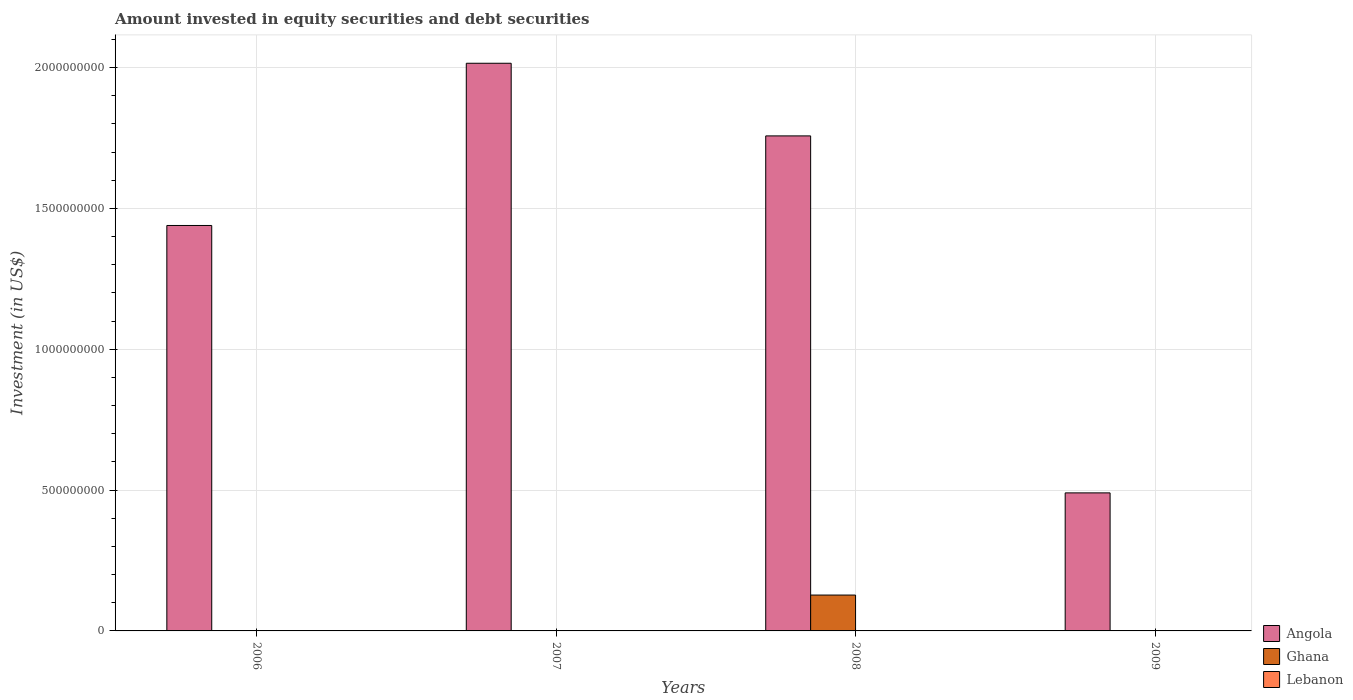How many different coloured bars are there?
Make the answer very short. 2. Are the number of bars per tick equal to the number of legend labels?
Offer a terse response. No. Are the number of bars on each tick of the X-axis equal?
Make the answer very short. No. What is the label of the 1st group of bars from the left?
Your response must be concise. 2006. In how many cases, is the number of bars for a given year not equal to the number of legend labels?
Offer a very short reply. 4. Across all years, what is the maximum amount invested in equity securities and debt securities in Ghana?
Provide a short and direct response. 1.27e+08. What is the total amount invested in equity securities and debt securities in Ghana in the graph?
Your response must be concise. 1.27e+08. What is the difference between the amount invested in equity securities and debt securities in Angola in 2006 and that in 2007?
Your response must be concise. -5.76e+08. What is the difference between the amount invested in equity securities and debt securities in Lebanon in 2009 and the amount invested in equity securities and debt securities in Angola in 2006?
Provide a short and direct response. -1.44e+09. What is the average amount invested in equity securities and debt securities in Angola per year?
Keep it short and to the point. 1.43e+09. In the year 2008, what is the difference between the amount invested in equity securities and debt securities in Ghana and amount invested in equity securities and debt securities in Angola?
Provide a short and direct response. -1.63e+09. In how many years, is the amount invested in equity securities and debt securities in Angola greater than 1500000000 US$?
Provide a succinct answer. 2. What is the ratio of the amount invested in equity securities and debt securities in Angola in 2008 to that in 2009?
Provide a succinct answer. 3.59. Is the amount invested in equity securities and debt securities in Angola in 2007 less than that in 2008?
Make the answer very short. No. What is the difference between the highest and the second highest amount invested in equity securities and debt securities in Angola?
Your answer should be compact. 2.58e+08. What is the difference between the highest and the lowest amount invested in equity securities and debt securities in Ghana?
Offer a terse response. 1.27e+08. Is the sum of the amount invested in equity securities and debt securities in Angola in 2007 and 2009 greater than the maximum amount invested in equity securities and debt securities in Ghana across all years?
Your response must be concise. Yes. Is it the case that in every year, the sum of the amount invested in equity securities and debt securities in Angola and amount invested in equity securities and debt securities in Ghana is greater than the amount invested in equity securities and debt securities in Lebanon?
Keep it short and to the point. Yes. How many bars are there?
Your answer should be very brief. 5. Are all the bars in the graph horizontal?
Offer a very short reply. No. How many years are there in the graph?
Give a very brief answer. 4. Does the graph contain any zero values?
Your answer should be very brief. Yes. Does the graph contain grids?
Ensure brevity in your answer.  Yes. What is the title of the graph?
Ensure brevity in your answer.  Amount invested in equity securities and debt securities. Does "Fragile and conflict affected situations" appear as one of the legend labels in the graph?
Offer a terse response. No. What is the label or title of the Y-axis?
Give a very brief answer. Investment (in US$). What is the Investment (in US$) in Angola in 2006?
Keep it short and to the point. 1.44e+09. What is the Investment (in US$) in Lebanon in 2006?
Keep it short and to the point. 0. What is the Investment (in US$) in Angola in 2007?
Offer a terse response. 2.02e+09. What is the Investment (in US$) in Lebanon in 2007?
Provide a short and direct response. 0. What is the Investment (in US$) in Angola in 2008?
Give a very brief answer. 1.76e+09. What is the Investment (in US$) in Ghana in 2008?
Your answer should be very brief. 1.27e+08. What is the Investment (in US$) of Lebanon in 2008?
Your response must be concise. 0. What is the Investment (in US$) of Angola in 2009?
Your answer should be compact. 4.90e+08. Across all years, what is the maximum Investment (in US$) of Angola?
Make the answer very short. 2.02e+09. Across all years, what is the maximum Investment (in US$) of Ghana?
Your response must be concise. 1.27e+08. Across all years, what is the minimum Investment (in US$) of Angola?
Your answer should be very brief. 4.90e+08. What is the total Investment (in US$) of Angola in the graph?
Offer a terse response. 5.70e+09. What is the total Investment (in US$) in Ghana in the graph?
Keep it short and to the point. 1.27e+08. What is the difference between the Investment (in US$) of Angola in 2006 and that in 2007?
Keep it short and to the point. -5.76e+08. What is the difference between the Investment (in US$) in Angola in 2006 and that in 2008?
Your answer should be very brief. -3.18e+08. What is the difference between the Investment (in US$) in Angola in 2006 and that in 2009?
Provide a short and direct response. 9.49e+08. What is the difference between the Investment (in US$) of Angola in 2007 and that in 2008?
Make the answer very short. 2.58e+08. What is the difference between the Investment (in US$) in Angola in 2007 and that in 2009?
Ensure brevity in your answer.  1.53e+09. What is the difference between the Investment (in US$) in Angola in 2008 and that in 2009?
Make the answer very short. 1.27e+09. What is the difference between the Investment (in US$) in Angola in 2006 and the Investment (in US$) in Ghana in 2008?
Your response must be concise. 1.31e+09. What is the difference between the Investment (in US$) of Angola in 2007 and the Investment (in US$) of Ghana in 2008?
Your response must be concise. 1.89e+09. What is the average Investment (in US$) in Angola per year?
Keep it short and to the point. 1.43e+09. What is the average Investment (in US$) of Ghana per year?
Make the answer very short. 3.18e+07. In the year 2008, what is the difference between the Investment (in US$) in Angola and Investment (in US$) in Ghana?
Make the answer very short. 1.63e+09. What is the ratio of the Investment (in US$) in Angola in 2006 to that in 2007?
Ensure brevity in your answer.  0.71. What is the ratio of the Investment (in US$) in Angola in 2006 to that in 2008?
Provide a short and direct response. 0.82. What is the ratio of the Investment (in US$) of Angola in 2006 to that in 2009?
Provide a succinct answer. 2.94. What is the ratio of the Investment (in US$) in Angola in 2007 to that in 2008?
Keep it short and to the point. 1.15. What is the ratio of the Investment (in US$) in Angola in 2007 to that in 2009?
Ensure brevity in your answer.  4.11. What is the ratio of the Investment (in US$) of Angola in 2008 to that in 2009?
Keep it short and to the point. 3.59. What is the difference between the highest and the second highest Investment (in US$) of Angola?
Provide a short and direct response. 2.58e+08. What is the difference between the highest and the lowest Investment (in US$) in Angola?
Your answer should be compact. 1.53e+09. What is the difference between the highest and the lowest Investment (in US$) of Ghana?
Make the answer very short. 1.27e+08. 